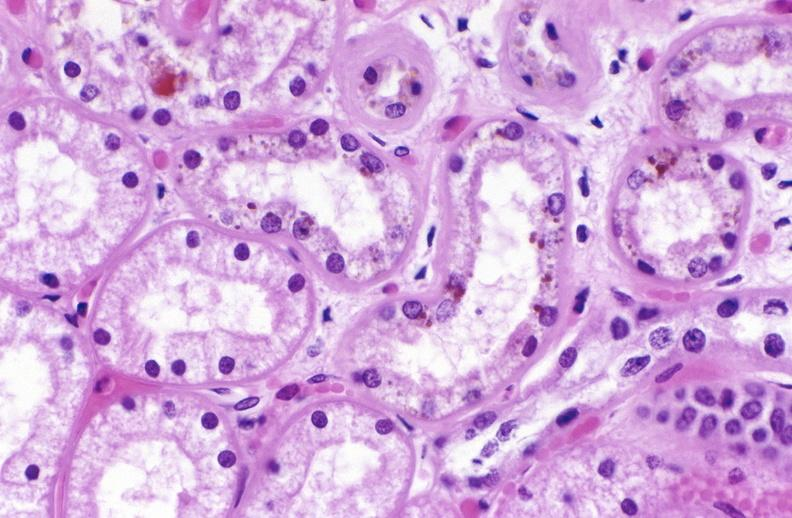what is present?
Answer the question using a single word or phrase. Urinary 